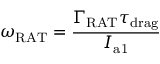Convert formula to latex. <formula><loc_0><loc_0><loc_500><loc_500>\omega _ { R A T } = \frac { \Gamma _ { R A T } \tau _ { d r a g } } { I _ { a 1 } }</formula> 